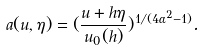<formula> <loc_0><loc_0><loc_500><loc_500>a ( u , \eta ) = ( \frac { u + h \eta } { u _ { 0 } ( h ) } ) ^ { 1 / ( 4 \alpha ^ { 2 } - 1 ) } .</formula> 